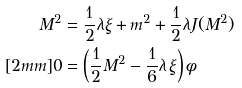Convert formula to latex. <formula><loc_0><loc_0><loc_500><loc_500>M ^ { 2 } & = \frac { 1 } { 2 } \lambda \xi + m ^ { 2 } + \frac { 1 } { 2 } \lambda J ( M ^ { 2 } ) \\ [ 2 m m ] 0 & = \left ( \frac { 1 } { 2 } M ^ { 2 } - \frac { 1 } { 6 } \lambda \, \xi \right ) \phi</formula> 